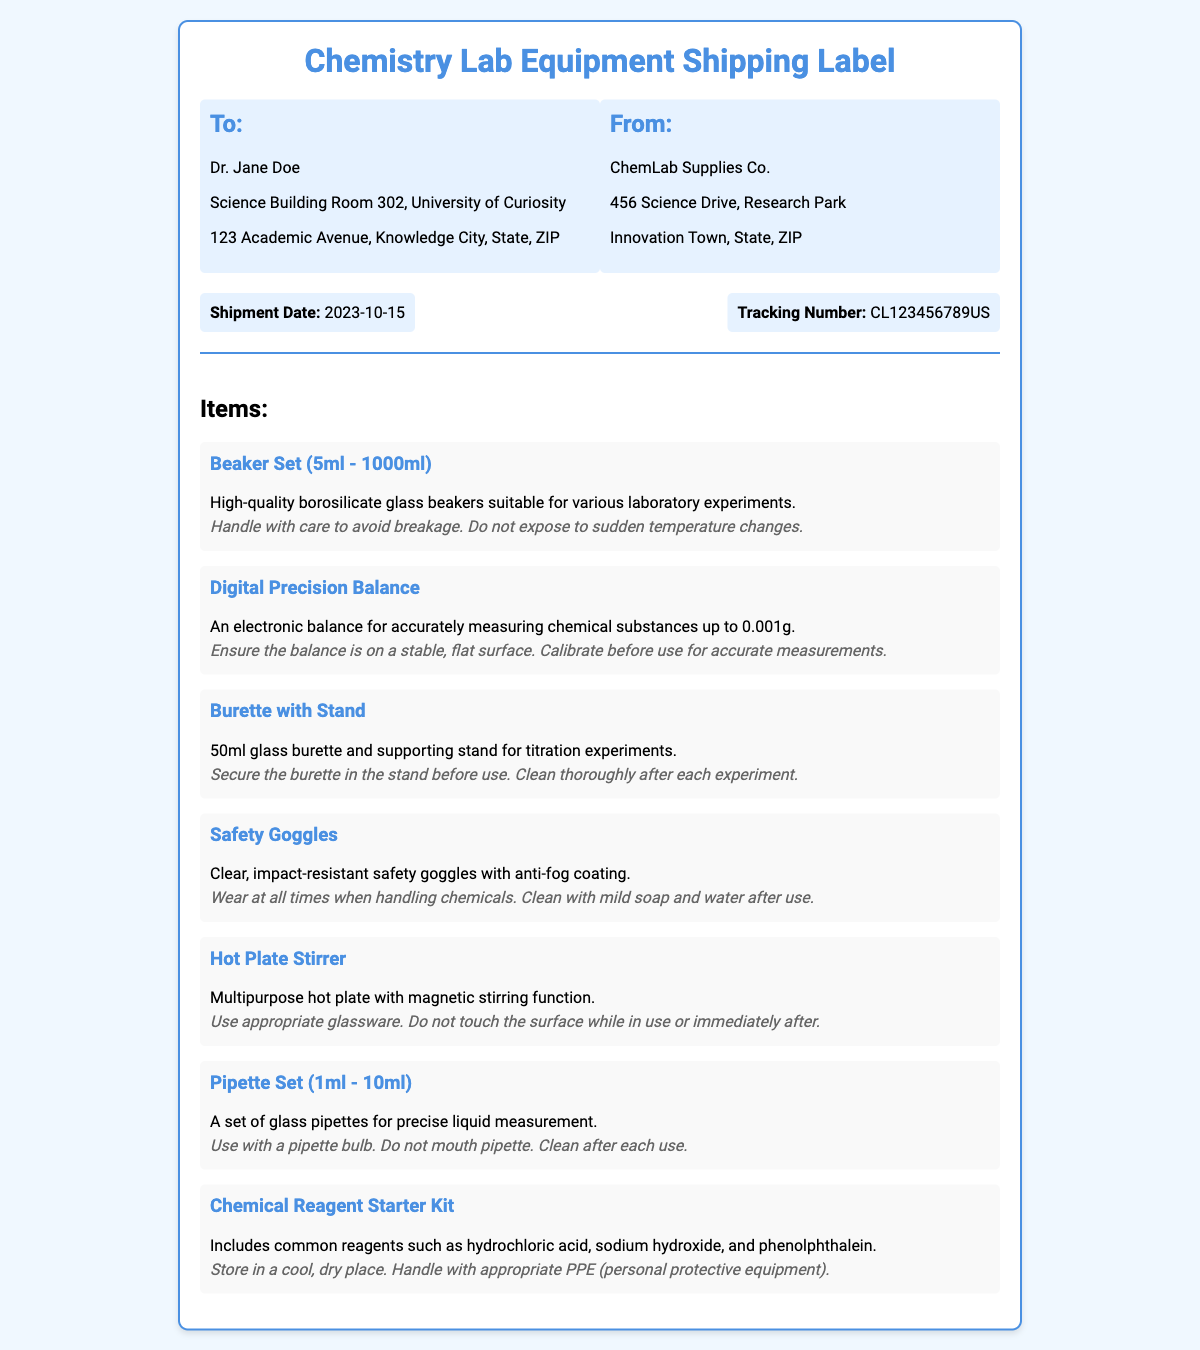What is the shipment date? The shipment date is mentioned in the shipment info section as "2023-10-15".
Answer: 2023-10-15 Who is the recipient of the shipment? The recipient's name is provided in the "To" section of the document, which states "Dr. Jane Doe".
Answer: Dr. Jane Doe What item is used for titration experiments? The item listed for titration experiments is the "Burette with Stand".
Answer: Burette with Stand How many milliliters can the Hot Plate Stirrer handle? The document does not specify the limitation in milliliters for the Hot Plate Stirrer; it is a multipurpose item.
Answer: Multipurpose What is the tracking number? The tracking number is listed in the shipment info as "CL123456789US".
Answer: CL123456789US What handling instruction is provided for safety goggles? The handling instruction includes that they should be "worn at all times when handling chemicals".
Answer: Wear at all times when handling chemicals Which company is sending the shipment? The sender's name is listed in the "From" section, which states "ChemLab Supplies Co.".
Answer: ChemLab Supplies Co How many items are listed under the items section? The document contains a total of seven items listed in the items section.
Answer: Seven items 